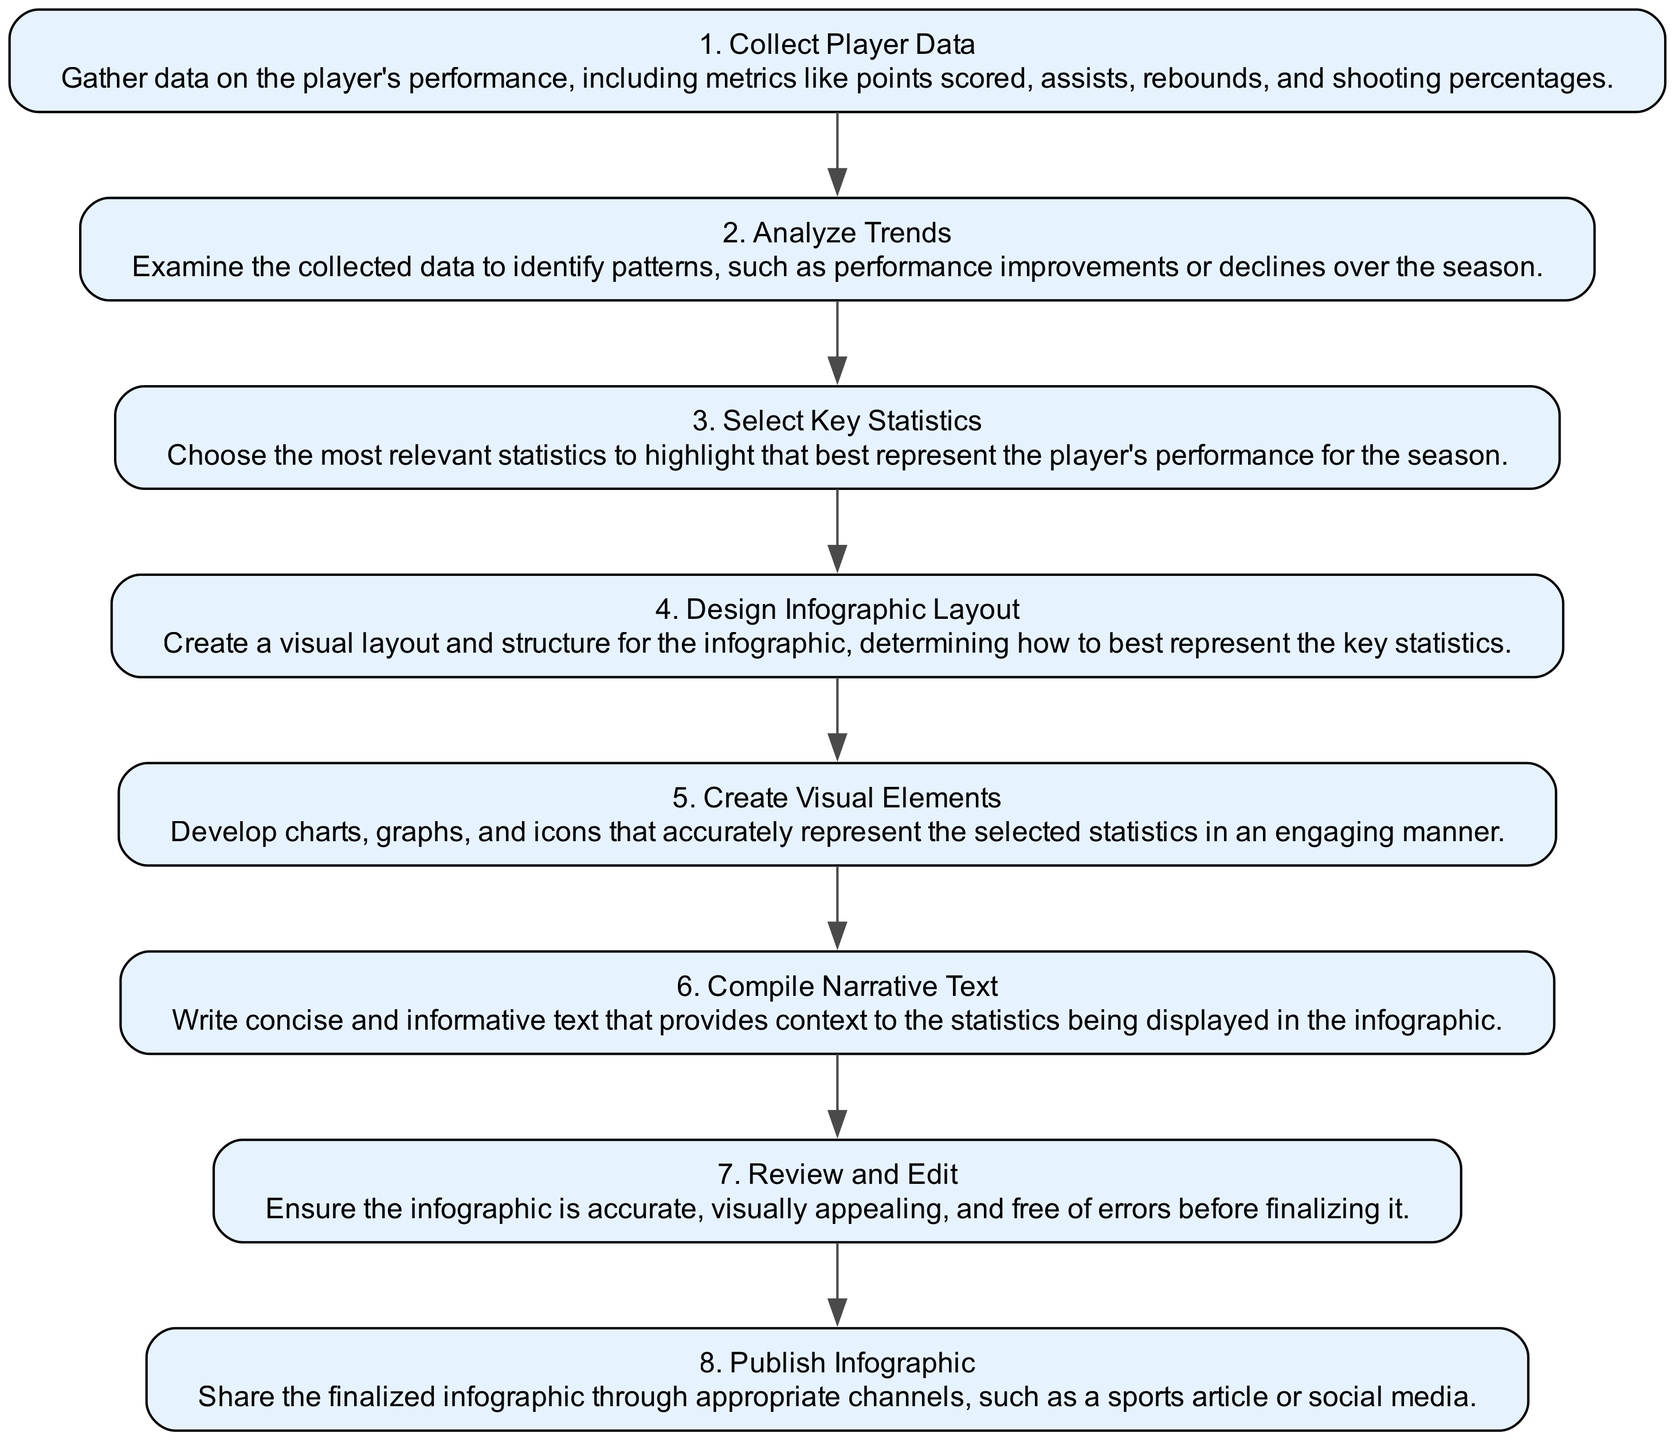What is the first step in the workflow? The first step listed in the diagram is "Collect Player Data," which indicates that the workflow begins with gathering performance data.
Answer: Collect Player Data How many total steps are there in the workflow? Counting all nodes in the diagram, there are a total of eight steps focusing on different parts of the infographic creation process.
Answer: Eight What step comes immediately after "Analyze Trends"? The diagram shows that immediately following "Analyze Trends," the next step is "Select Key Statistics," indicating a sequential workflow.
Answer: Select Key Statistics Which steps involve the creation of visual elements? The steps "Design Infographic Layout" and "Create Visual Elements" both focus on the development and representation of the visual aspects of the infographic.
Answer: Design Infographic Layout, Create Visual Elements What is the last step in the workflow? The final step in the sequence is "Publish Infographic," indicating that after all other steps, the infographic is shared or published.
Answer: Publish Infographic How does "Compile Narrative Text" relate to the visual elements? "Compile Narrative Text" provides context to the visual elements created earlier, emphasizing the importance of narrative alongside visual representation.
Answer: Provides context Which steps are directly related to data collection and analysis? "Collect Player Data" and "Analyze Trends" are directly related, as one involves gathering data while the other involves analyzing that data for trends.
Answer: Collect Player Data, Analyze Trends What two steps precede "Review and Edit"? The steps that come before "Review and Edit" are "Create Visual Elements" and "Compile Narrative Text," both of which are necessary to complete before reviewing the final infographic.
Answer: Create Visual Elements, Compile Narrative Text 